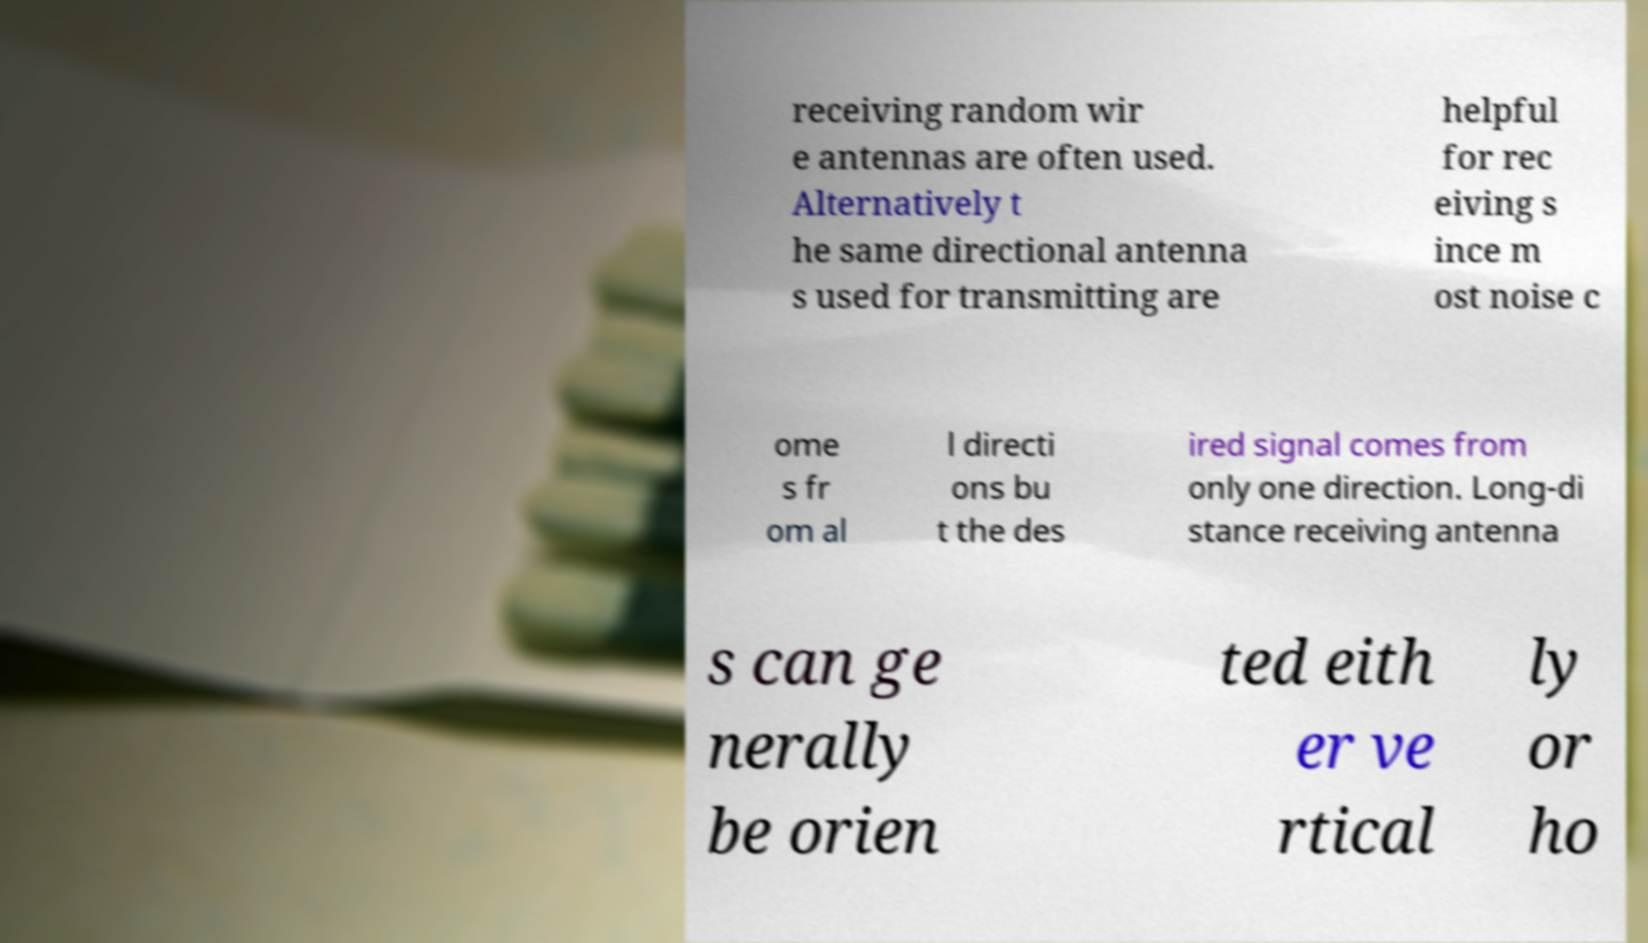What messages or text are displayed in this image? I need them in a readable, typed format. receiving random wir e antennas are often used. Alternatively t he same directional antenna s used for transmitting are helpful for rec eiving s ince m ost noise c ome s fr om al l directi ons bu t the des ired signal comes from only one direction. Long-di stance receiving antenna s can ge nerally be orien ted eith er ve rtical ly or ho 